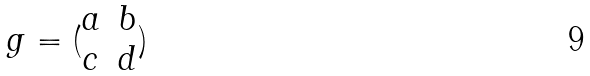<formula> <loc_0><loc_0><loc_500><loc_500>g = ( \begin{matrix} a & b \\ c & d \end{matrix} )</formula> 